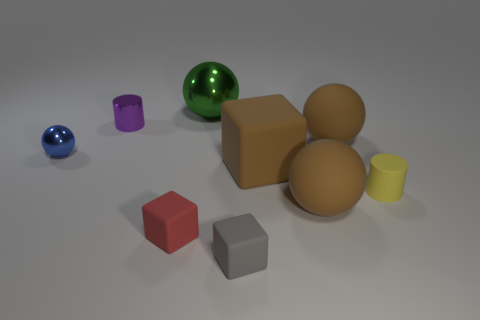What is the shape of the blue metal thing that is the same size as the purple shiny cylinder?
Offer a terse response. Sphere. There is a big rubber object behind the large brown matte thing that is left of the big brown matte ball that is in front of the tiny yellow matte thing; what shape is it?
Offer a terse response. Sphere. There is a small blue object; is it the same shape as the small thing that is to the right of the tiny gray rubber object?
Your response must be concise. No. What number of small things are either brown cubes or brown rubber cylinders?
Give a very brief answer. 0. Is there a gray cube that has the same size as the red object?
Make the answer very short. Yes. What is the color of the small cylinder behind the cylinder that is to the right of the small cylinder that is left of the big metallic thing?
Ensure brevity in your answer.  Purple. Do the purple cylinder and the big brown thing that is in front of the yellow object have the same material?
Ensure brevity in your answer.  No. The other shiny thing that is the same shape as the green object is what size?
Your answer should be compact. Small. Is the number of large matte spheres behind the purple cylinder the same as the number of cubes that are in front of the tiny red block?
Ensure brevity in your answer.  No. What number of other objects are the same material as the large green sphere?
Your response must be concise. 2. 